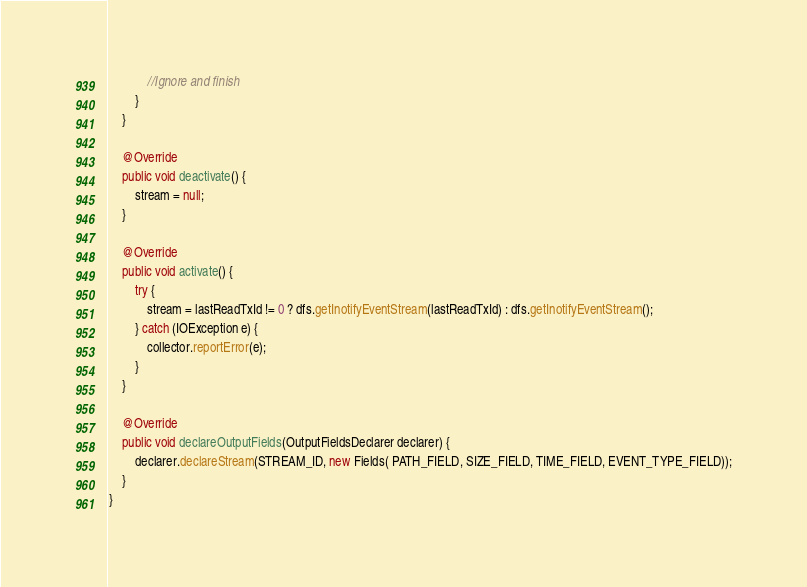<code> <loc_0><loc_0><loc_500><loc_500><_Java_>            //Ignore and finish
        }
    }
    
    @Override
    public void deactivate() {
        stream = null;
    }
    
    @Override
    public void activate() {
        try {
            stream = lastReadTxId != 0 ? dfs.getInotifyEventStream(lastReadTxId) : dfs.getInotifyEventStream();
        } catch (IOException e) {
            collector.reportError(e);
        }
    }

    @Override
    public void declareOutputFields(OutputFieldsDeclarer declarer) {
        declarer.declareStream(STREAM_ID, new Fields( PATH_FIELD, SIZE_FIELD, TIME_FIELD, EVENT_TYPE_FIELD));
    }
}
</code> 